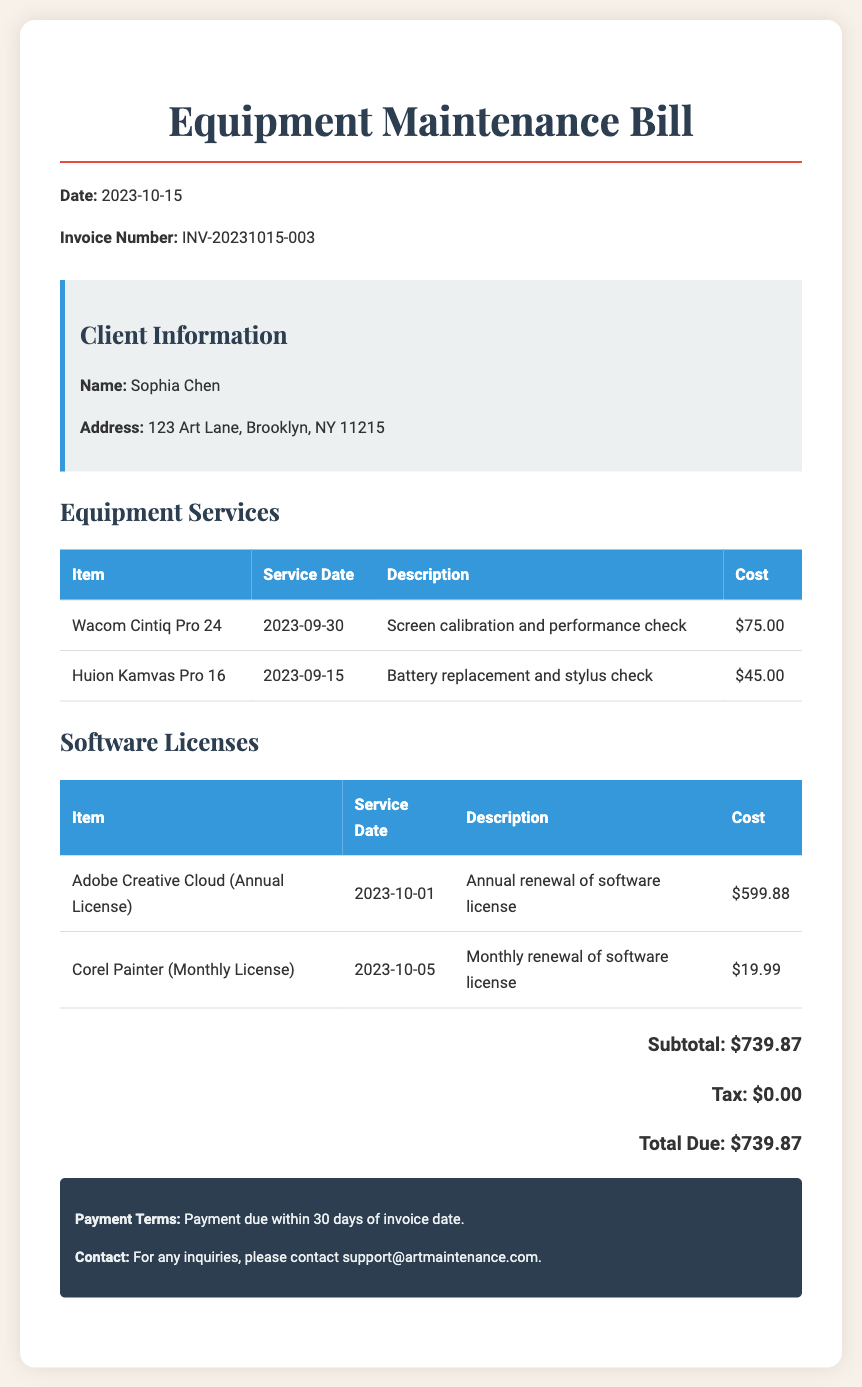What is the date of the invoice? The date of the invoice is found in the document's header section.
Answer: 2023-10-15 What is the invoice number? The invoice number is displayed prominently in the header of the document.
Answer: INV-20231015-003 Who is the client? The client's name is mentioned in the client information section.
Answer: Sophia Chen What item had service on 2023-09-15? The service date and relevant item are listed in the equipment services section.
Answer: Huion Kamvas Pro 16 What was the cost of Adobe Creative Cloud? The cost of the software license is included in the software licenses table.
Answer: $599.88 What is the total due for this bill? The total amount due is calculated in the summary at the bottom of the document.
Answer: $739.87 What type of service was performed on Wacom Cintiq Pro 24? The description for the service includes details of the work completed.
Answer: Screen calibration and performance check What is the tax amount for this bill? The tax amount is specified in the total summary section.
Answer: $0.00 How long does the client have to make payment? The payment terms are mentioned in the footer of the document.
Answer: 30 days 